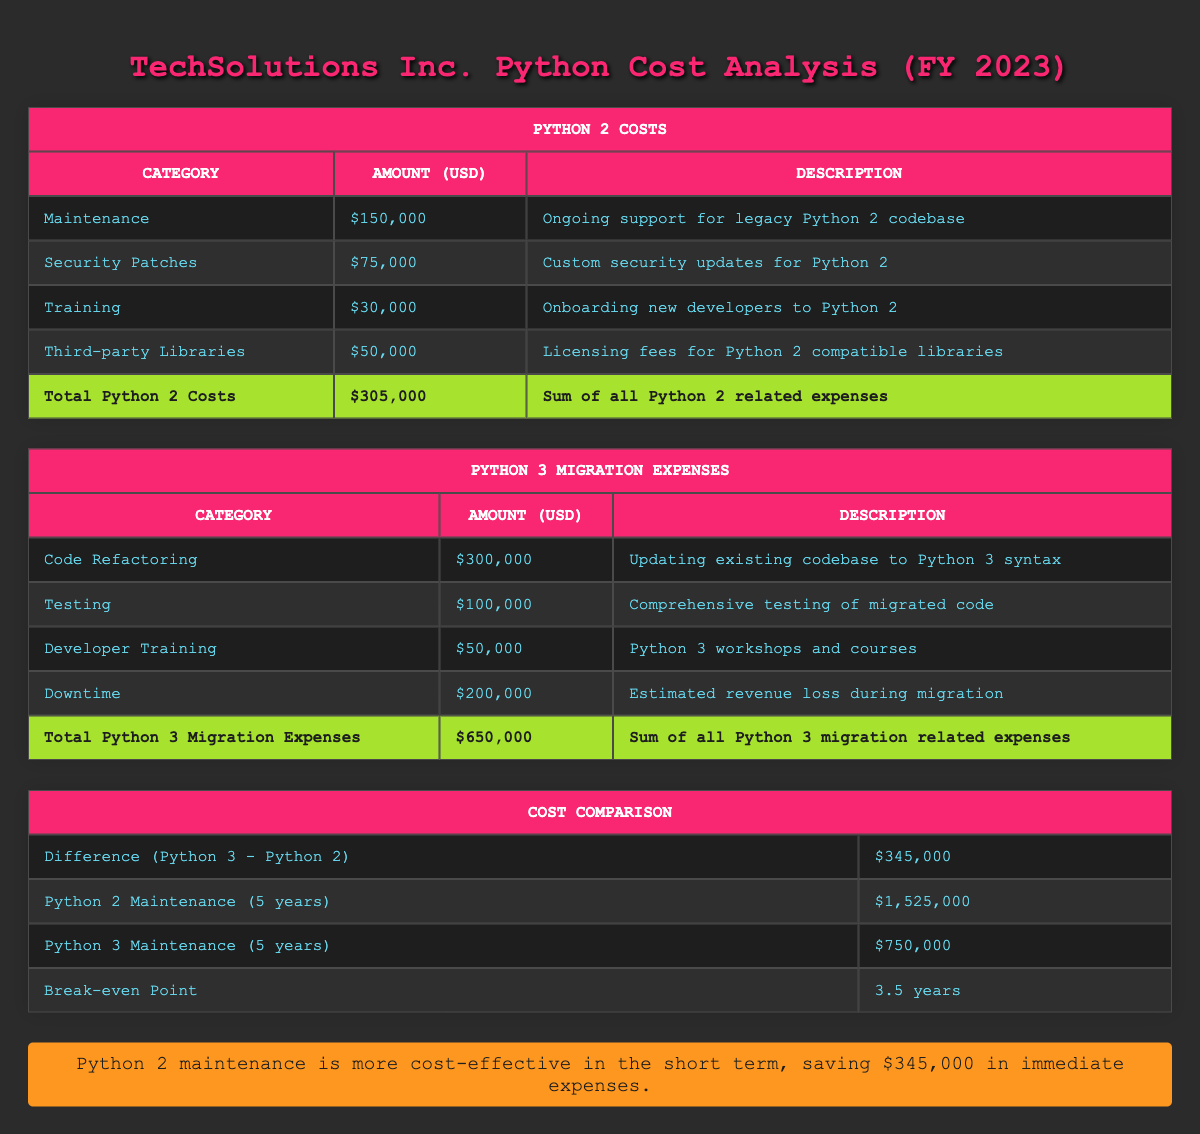What is the total cost for Python 2 maintenance? The table under the Python 2 Costs section shows that the total amount for Python 2 costs is listed as $305,000.
Answer: $305,000 How much does the company spend on security patches for Python 2? In the Python 2 Costs section, the row for Security Patches states an amount of $75,000.
Answer: $75,000 What is the difference in total costs between Python 2 and Python 3? The Cost Comparison table indicates that the difference (Python 3 migration expenses minus Python 2 costs) is $345,000.
Answer: $345,000 If Python 3 migration expenses are made, how much would the company have spent in the first year after migration versus sticking with Python 2? The first year expenses if staying with Python 2 are equal to $305,000. In contrast, for Python 3 migration expenses, the projected expenses for Code Refactoring, Testing, Developer Training, and Downtime sum to $650,000. Therefore, the difference in expenses in the first year is $650,000 - $305,000 = $345,000.
Answer: $345,000 Is the total maintenance cost for Python 2 over five years higher than Python 3 maintenance costs within the same period? The Python 2 maintenance over five years is stated as $1,525,000, while Python 3 maintenance over five years costs $750,000. Since $1,525,000 is greater than $750,000, the statement is true.
Answer: Yes How long until the company reaches a breakeven point regarding Python 2 and Python 3 costs? The table indicates that the breakeven point occurs in 3.5 years, meaning this is the time required for costs related to Python 3 to equal those of Python 2 maintaining expenses in a comparative manner.
Answer: 3.5 years What is the largest single expense category when migrating to Python 3? Reviewing the Python 3 Migration Expenses table, Code Refactoring has the highest amount recorded at $300,000.
Answer: $300,000 What total amount is spent on developer training across both Python versions? Summing the Developer Training categories from both tables gives $30,000 (for Python 2) + $50,000 (for Python 3) = $80,000 for developer training overall.
Answer: $80,000 